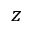<formula> <loc_0><loc_0><loc_500><loc_500>z</formula> 